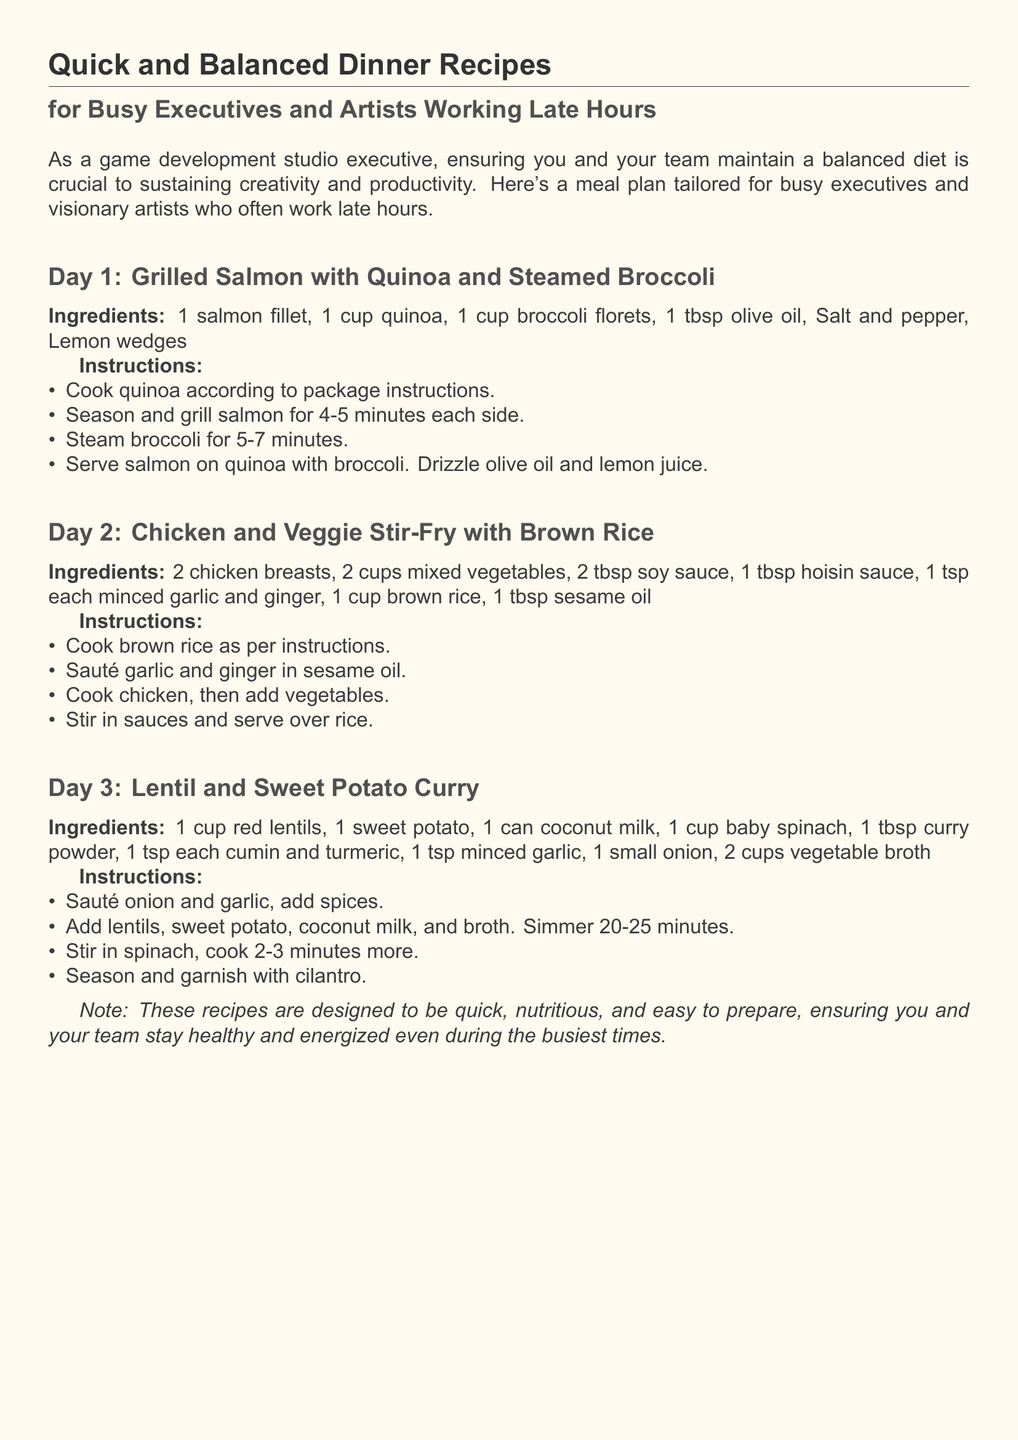What is the title of the document? The title is indicated at the top of the document, highlighting the main subject.
Answer: Quick and Balanced Dinner Recipes How many dinner recipes are provided? The document lists three specific dinner recipes.
Answer: Three What is the main ingredient in Day 1's recipe? Day 1's recipe focuses on a particular protein source, as stated in the ingredients.
Answer: Salmon What type of rice is used in Day 2's recipe? The ingredient list specifies the type of rice required for this particular dish.
Answer: Brown rice What vegetable is included in Day 3's curry? The recipe mentions a specific vegetable that is added to the curry towards the end of cooking.
Answer: Spinach How long does Day 3's curry need to simmer? The cooking instructions specify the duration for simmering the ingredients together.
Answer: 20-25 minutes What seasoning is used in Day 2's stir-fry? The instructions indicate sauces that are added to enhance flavor in this dish.
Answer: Soy sauce Which cooking method is used for the salmon in Day 1? The instructions specify how the salmon should be prepared in relation to heat and time.
Answer: Grilled What dietary benefit does the document claim the recipes provide? The introduction mentions a specific outcome related to health and productivity from following the recipes.
Answer: Nutritional balance 